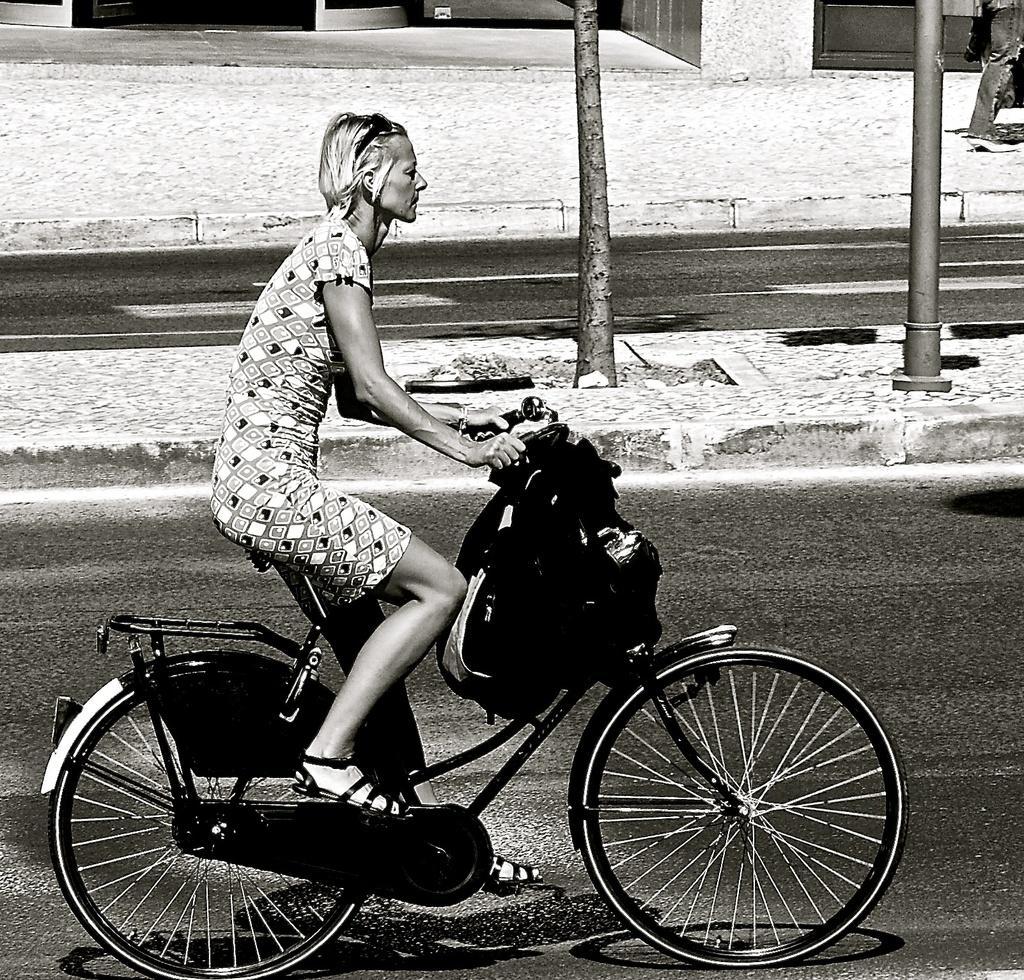Describe this image in one or two sentences. In this image I can see a person riding the bicycle. And to the left of that person there is a branch of tree and the pole. 